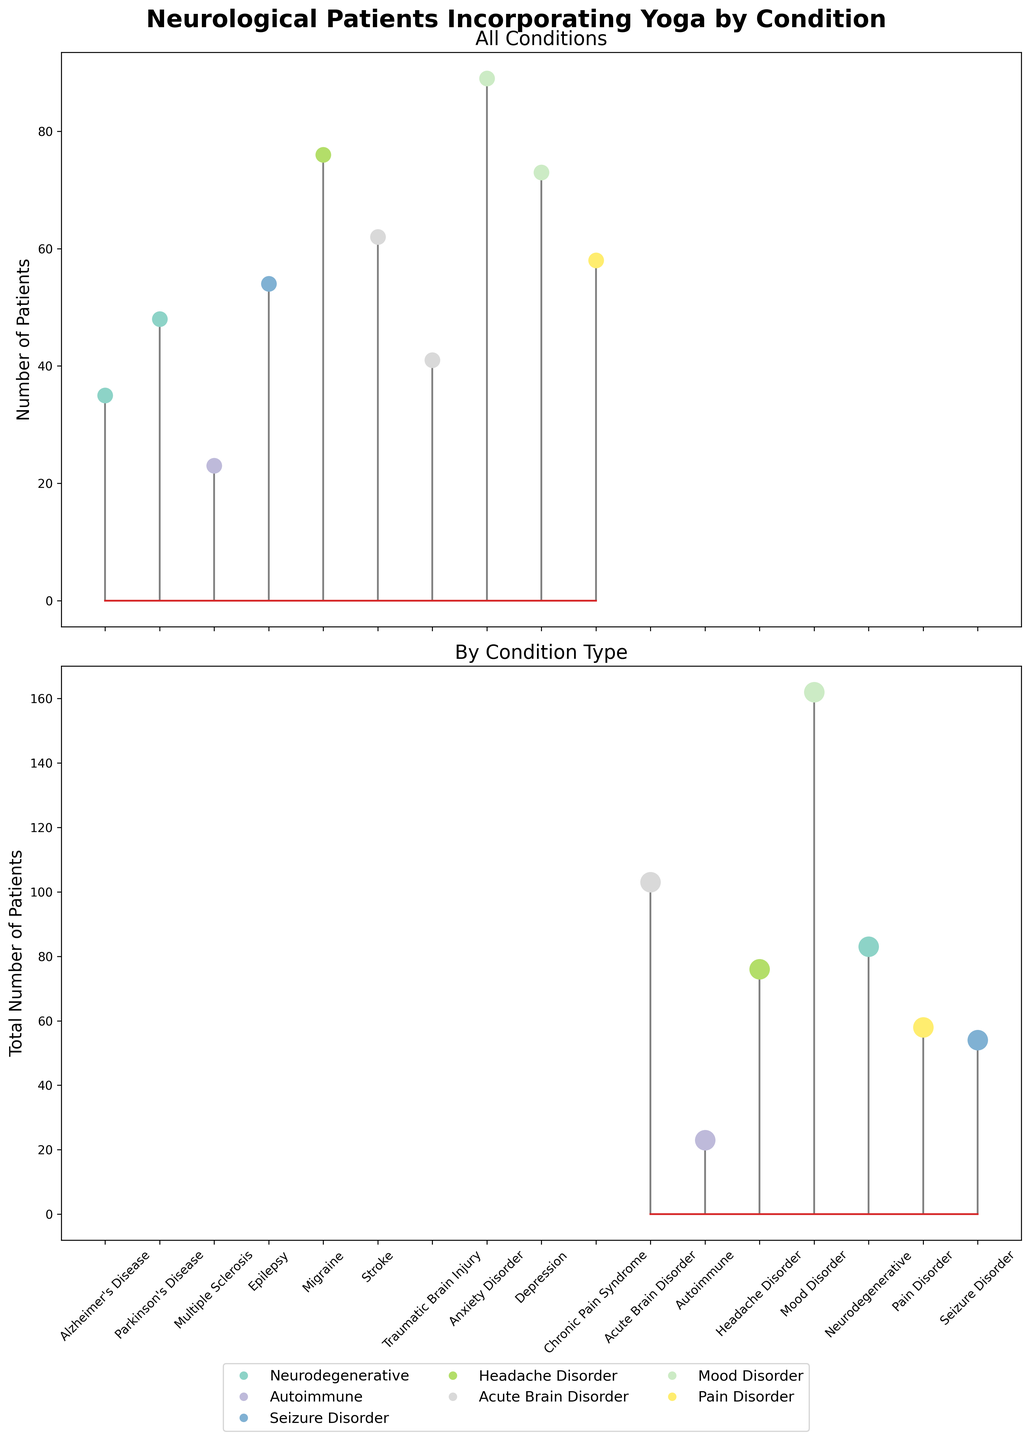How many conditions are represented in the first subplot? Count the number of unique conditions on the x-axis of the first subplot.
Answer: 10 Which condition has the highest number of patients incorporating yoga in their treatment plan? Identify the condition with the highest stem height in the first subplot.
Answer: Migraine What is the total number of patients with mood disorders incorporating yoga? Sum the patient numbers for Anxiety Disorder and Depression from the first subplot.
Answer: 162 How does the number of patients with Epilepsy compare to those with Stroke? Compare the stem heights for Epilepsy and Stroke from the first subplot.
Answer: Epilepsy has fewer patients than Stroke Which condition type has the fewest total number of patients incorporating yoga? Identify the condition type with the shortest stem height in the second subplot.
Answer: Autoimmune What's the average number of neurological patients incorporating yoga across all conditions? Sum the number of patients for all conditions in the first subplot and divide by the number of conditions. (35 + 48 + 23 + 54 + 76 + 62 + 41 + 89 + 73 + 58) / 10 = 559 / 10.
Answer: 55.9 Are there more patients with Neurodegenerative conditions or Acute Brain Disorders incorporating yoga? Compare the total number of patients between these two condition types from the second subplot.
Answer: Acute Brain Disorders have more patients Which two conditions have the closest number of patients incorporating yoga? Look for the two conditions with the most similar stem heights from the first subplot.
Answer: Chronic Pain Syndrome and Stroke What is the color used to represent Mood Disorders in the legend? Identify the color corresponding to Mood Disorders from the figure legend.
Answer: (whatever color is used) List all condition types and the number of patients associated with each in the second subplot. Read off each condition type and its corresponding total number of patients from the second subplot.
Answer: Acute Brain Disorder: 103, Autoimmune: 23, Headache Disorder: 76, Mood Disorder: 162, Neurodegenerative: 83, Pain Disorder: 58, Seizure Disorder: 54 